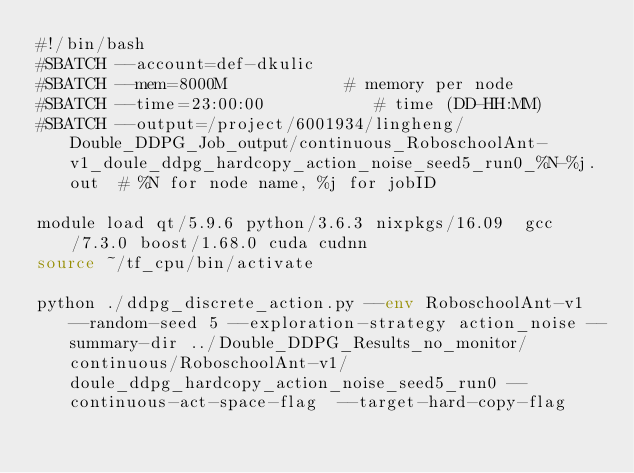Convert code to text. <code><loc_0><loc_0><loc_500><loc_500><_Bash_>#!/bin/bash
#SBATCH --account=def-dkulic
#SBATCH --mem=8000M            # memory per node
#SBATCH --time=23:00:00           # time (DD-HH:MM)
#SBATCH --output=/project/6001934/lingheng/Double_DDPG_Job_output/continuous_RoboschoolAnt-v1_doule_ddpg_hardcopy_action_noise_seed5_run0_%N-%j.out  # %N for node name, %j for jobID

module load qt/5.9.6 python/3.6.3 nixpkgs/16.09  gcc/7.3.0 boost/1.68.0 cuda cudnn
source ~/tf_cpu/bin/activate

python ./ddpg_discrete_action.py --env RoboschoolAnt-v1 --random-seed 5 --exploration-strategy action_noise --summary-dir ../Double_DDPG_Results_no_monitor/continuous/RoboschoolAnt-v1/doule_ddpg_hardcopy_action_noise_seed5_run0 --continuous-act-space-flag  --target-hard-copy-flag 

</code> 